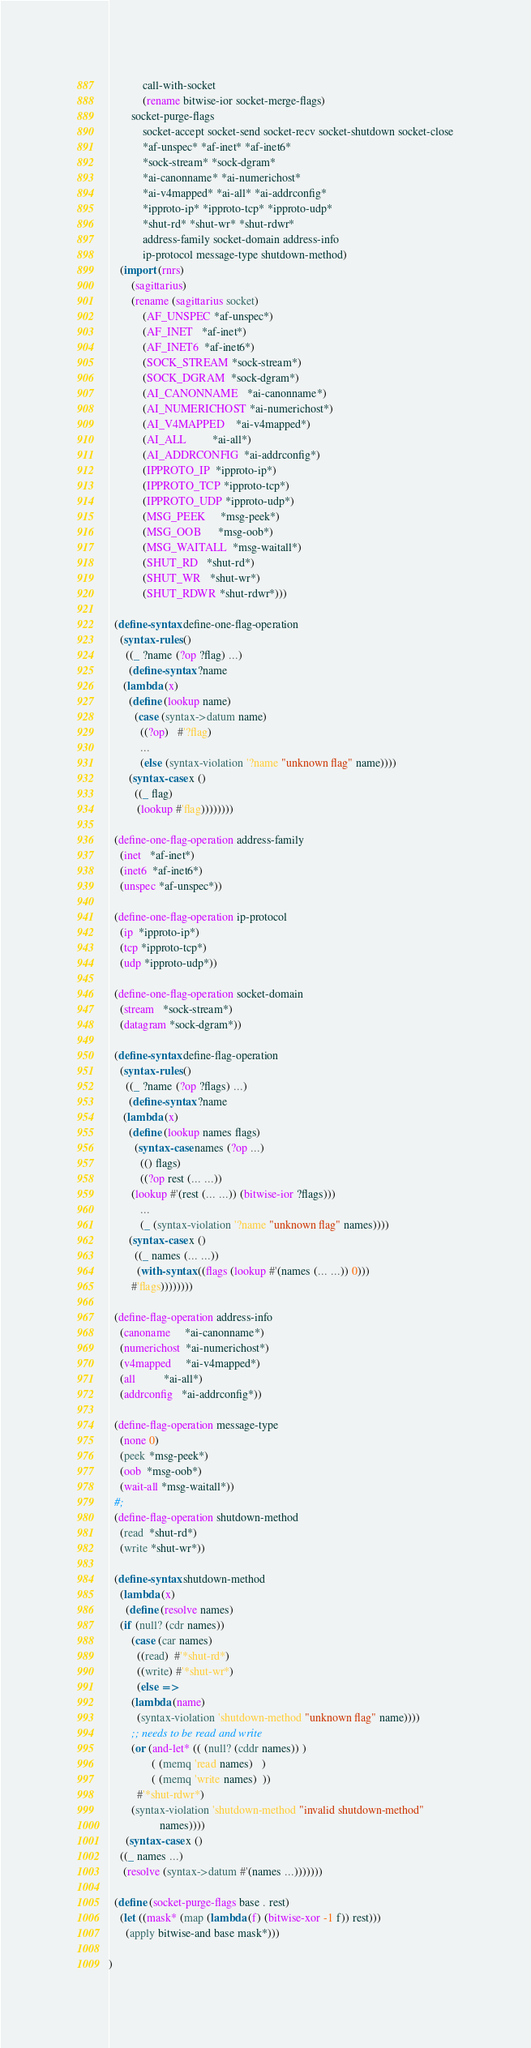Convert code to text. <code><loc_0><loc_0><loc_500><loc_500><_Scheme_>            call-with-socket
            (rename bitwise-ior socket-merge-flags)
	    socket-purge-flags
            socket-accept socket-send socket-recv socket-shutdown socket-close
            *af-unspec* *af-inet* *af-inet6*
            *sock-stream* *sock-dgram*
            *ai-canonname* *ai-numerichost*
            *ai-v4mapped* *ai-all* *ai-addrconfig*
            *ipproto-ip* *ipproto-tcp* *ipproto-udp*
            *shut-rd* *shut-wr* *shut-rdwr*
            address-family socket-domain address-info
            ip-protocol message-type shutdown-method)
    (import (rnrs) 
	    (sagittarius)
	    (rename (sagittarius socket) 
		    (AF_UNSPEC *af-unspec*)
		    (AF_INET   *af-inet*)
		    (AF_INET6  *af-inet6*)
		    (SOCK_STREAM *sock-stream*)
		    (SOCK_DGRAM  *sock-dgram*)
		    (AI_CANONNAME   *ai-canonname*)
		    (AI_NUMERICHOST *ai-numerichost*)
		    (AI_V4MAPPED    *ai-v4mapped*)
		    (AI_ALL         *ai-all*)
		    (AI_ADDRCONFIG  *ai-addrconfig*)
		    (IPPROTO_IP  *ipproto-ip*)
		    (IPPROTO_TCP *ipproto-tcp*)
		    (IPPROTO_UDP *ipproto-udp*)
		    (MSG_PEEK     *msg-peek*)
		    (MSG_OOB      *msg-oob*)
		    (MSG_WAITALL  *msg-waitall*)
		    (SHUT_RD   *shut-rd*)
		    (SHUT_WR   *shut-wr*)
		    (SHUT_RDWR *shut-rdwr*)))
  
  (define-syntax define-one-flag-operation
    (syntax-rules ()
      ((_ ?name (?op ?flag) ...)
       (define-syntax ?name
	 (lambda (x)
	   (define (lookup name)
	     (case (syntax->datum name)
	       ((?op)   #'?flag)
	       ...
	       (else (syntax-violation '?name "unknown flag" name))))
	   (syntax-case x ()
	     ((_ flag)
	      (lookup #'flag))))))))

  (define-one-flag-operation address-family
    (inet   *af-inet*)
    (inet6  *af-inet6*)
    (unspec *af-unspec*))

  (define-one-flag-operation ip-protocol
    (ip  *ipproto-ip*)
    (tcp *ipproto-tcp*)
    (udp *ipproto-udp*))

  (define-one-flag-operation socket-domain 
    (stream   *sock-stream*)
    (datagram *sock-dgram*))

  (define-syntax define-flag-operation
    (syntax-rules ()
      ((_ ?name (?op ?flags) ...)
       (define-syntax ?name
	 (lambda (x)
	   (define (lookup names flags)
	     (syntax-case names (?op ...)
	       (() flags)
	       ((?op rest (... ...)) 
		(lookup #'(rest (... ...)) (bitwise-ior ?flags)))
	       ...
	       (_ (syntax-violation '?name "unknown flag" names))))
	   (syntax-case x ()
	     ((_ names (... ...))
	      (with-syntax ((flags (lookup #'(names (... ...)) 0)))
		#'flags))))))))

  (define-flag-operation address-info
    (canoname     *ai-canonname*)
    (numerichost  *ai-numerichost*)
    (v4mapped     *ai-v4mapped*)
    (all          *ai-all*)
    (addrconfig   *ai-addrconfig*))

  (define-flag-operation message-type
    (none 0)
    (peek *msg-peek*)
    (oob  *msg-oob*)
    (wait-all *msg-waitall*))
  #;
  (define-flag-operation shutdown-method
    (read  *shut-rd*)
    (write *shut-wr*))

  (define-syntax shutdown-method
    (lambda (x)
      (define (resolve names)
	(if (null? (cdr names))
	    (case (car names)
	      ((read)  #'*shut-rd*)
	      ((write) #'*shut-wr*)
	      (else =>
		(lambda (name)
		  (syntax-violation 'shutdown-method "unknown flag" name))))
	    ;; needs to be read and write
	    (or (and-let* (( (null? (cddr names)) )
			   ( (memq 'read names)   )
			   ( (memq 'write names)  ))
		  #'*shut-rdwr*)
		(syntax-violation 'shutdown-method "invalid shutdown-method"
				  names))))
      (syntax-case x ()
	((_ names ...)
	 (resolve (syntax->datum #'(names ...)))))))

  (define (socket-purge-flags base . rest) 
    (let ((mask* (map (lambda (f) (bitwise-xor -1 f)) rest)))
      (apply bitwise-and base mask*)))

)</code> 